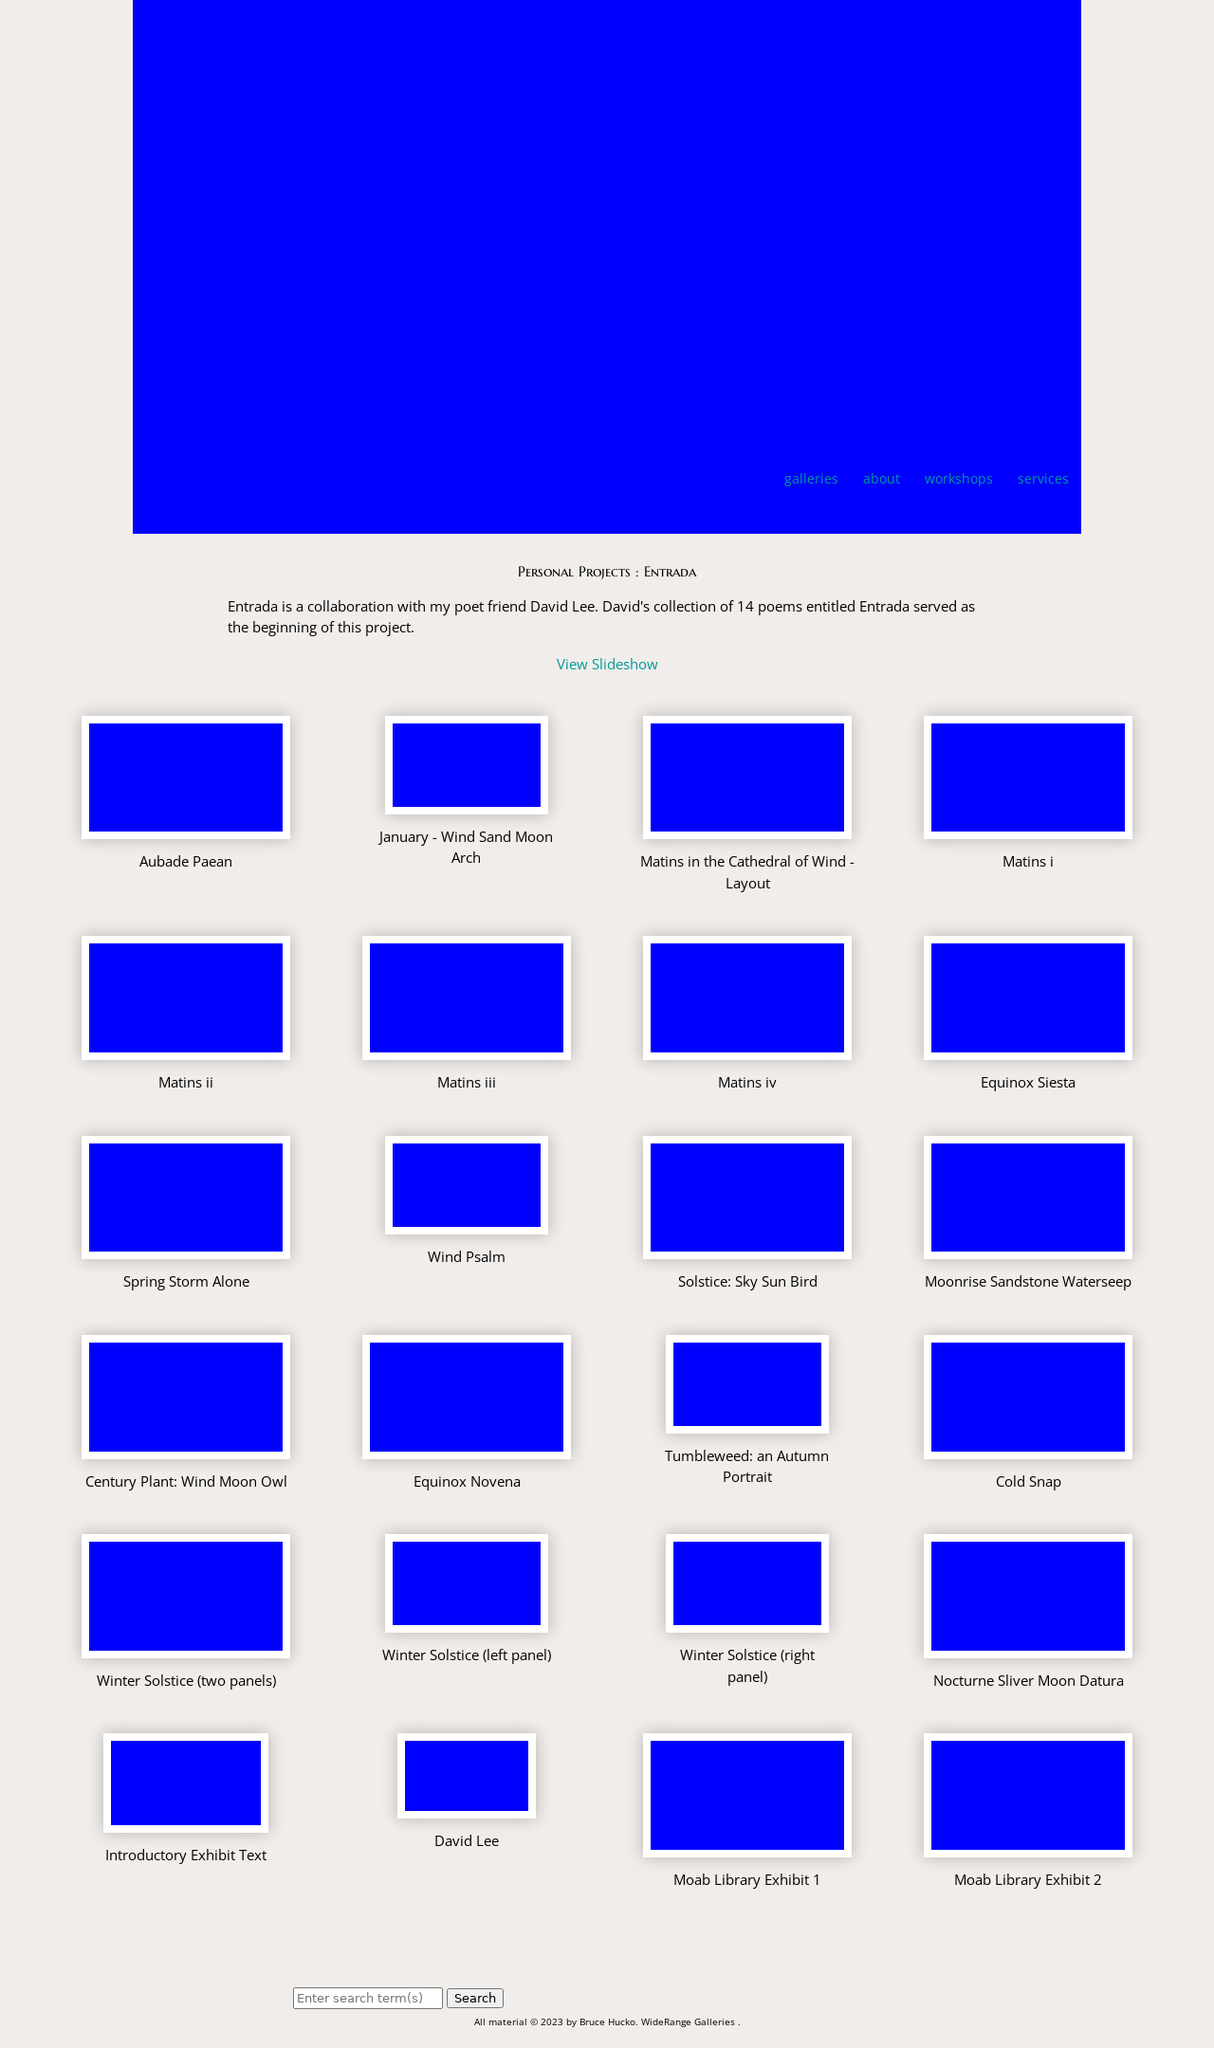How has the photographer's technique evolved in capturing such dynamic landscapes? Bruce Hucko's photographic technique has evolved to focus extensively on capturing the subtle nuances and changing light of landscapes, particularly those in desert environments. His use of light, shadow, and color depth helps in creating compelling images that are both vivid and evocative, reflecting a deep connection and understanding of the natural world.  What has been the reception to Bruce Hucko’s work at various exhibitions? Bruce Hucko’s work has been highly appreciated in various exhibitions for its authenticity and the emotional resonance it carries. His ability to present landscapes in their raw, untouched beauty has garnered him accolades and recognition within the art community, encouraging discussions around the interplay of natural beauty and artistic representation. 